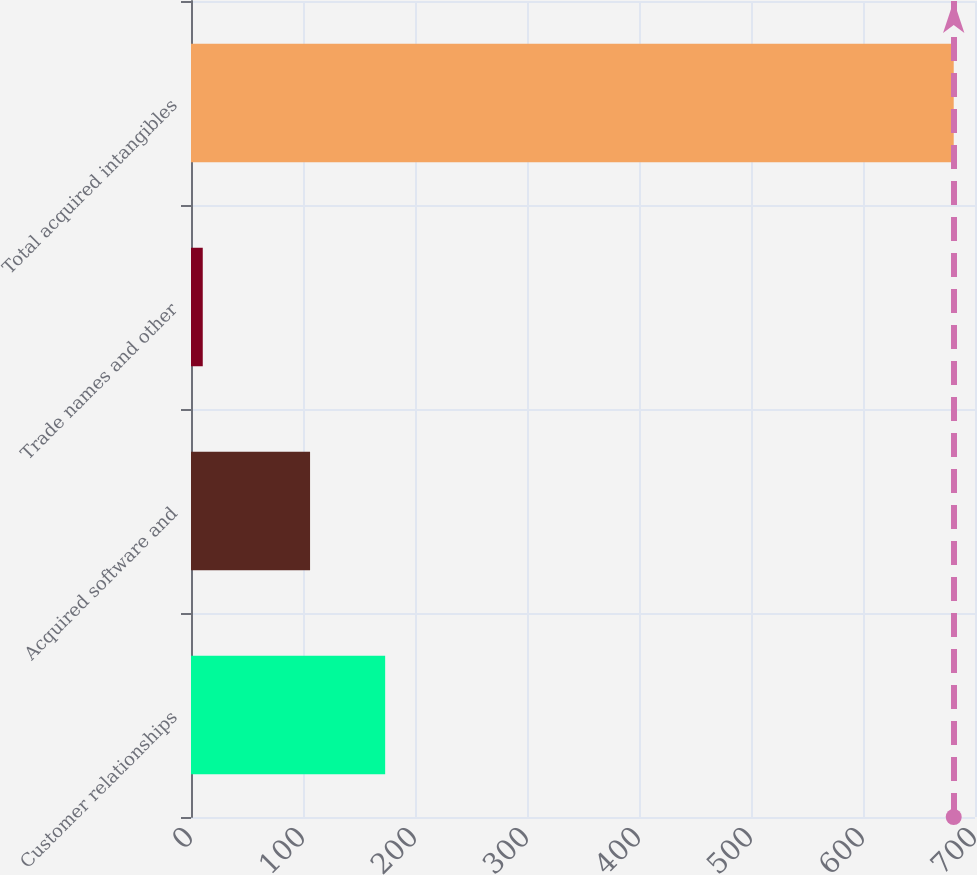Convert chart to OTSL. <chart><loc_0><loc_0><loc_500><loc_500><bar_chart><fcel>Customer relationships<fcel>Acquired software and<fcel>Trade names and other<fcel>Total acquired intangibles<nl><fcel>173.35<fcel>106.3<fcel>10.5<fcel>681<nl></chart> 